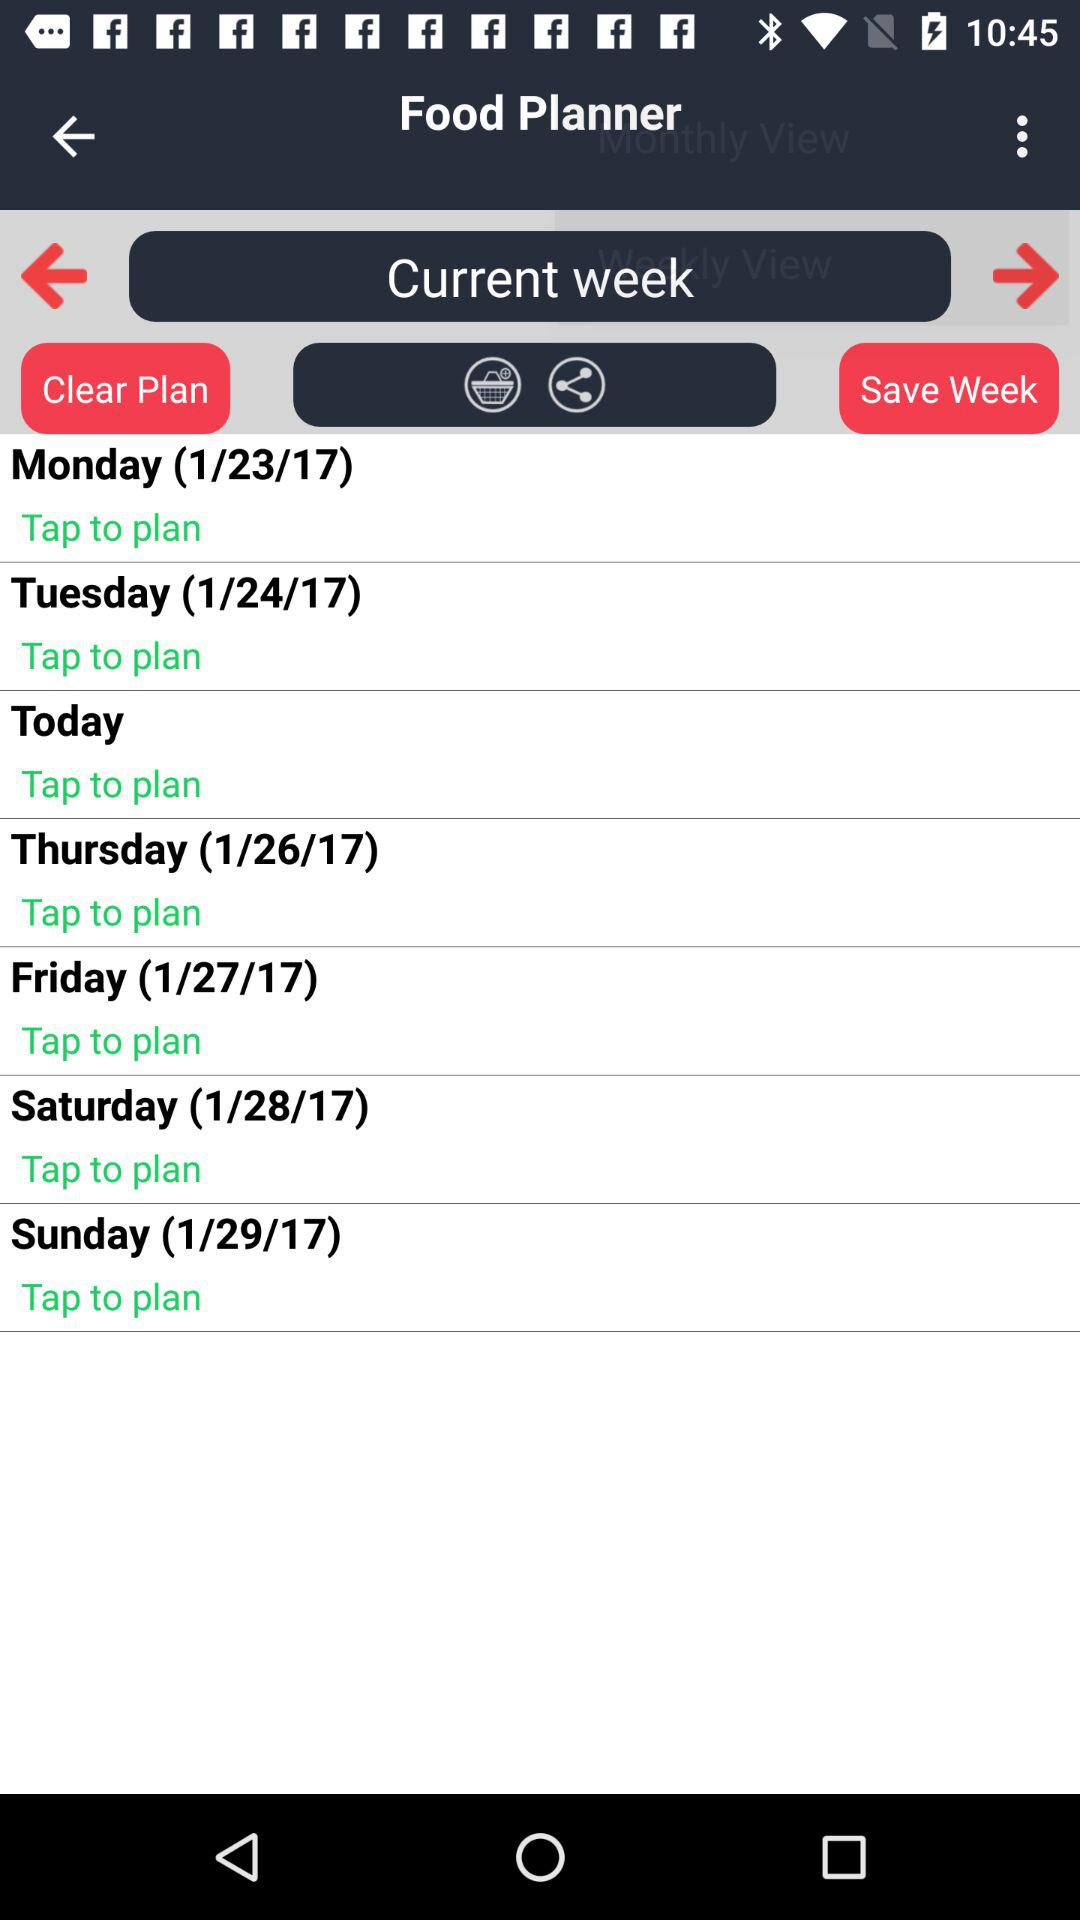Which day falls on 1/23/17? The day is Monday. 